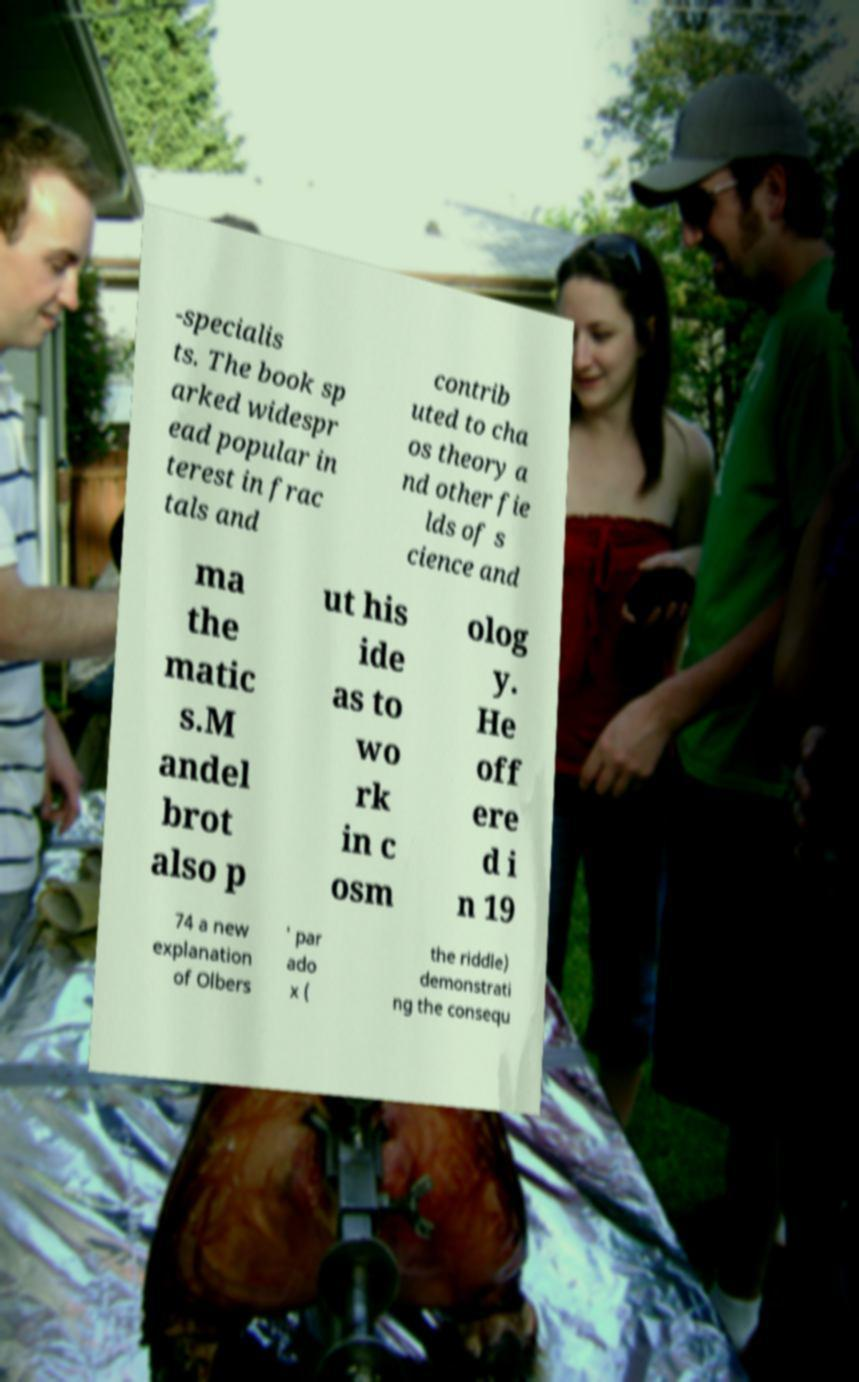What messages or text are displayed in this image? I need them in a readable, typed format. -specialis ts. The book sp arked widespr ead popular in terest in frac tals and contrib uted to cha os theory a nd other fie lds of s cience and ma the matic s.M andel brot also p ut his ide as to wo rk in c osm olog y. He off ere d i n 19 74 a new explanation of Olbers ' par ado x ( the riddle) demonstrati ng the consequ 